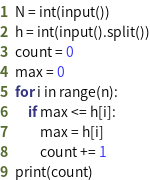<code> <loc_0><loc_0><loc_500><loc_500><_Python_>N = int(input())
h = int(input().split())
count = 0
max = 0
for i in range(n):
    if max <= h[i]:
        max = h[i]
        count += 1
print(count)</code> 